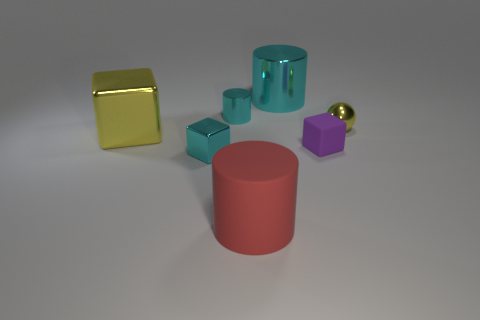Are there any large objects of the same color as the metallic sphere?
Ensure brevity in your answer.  Yes. Does the big cylinder behind the ball have the same color as the tiny shiny cylinder?
Provide a succinct answer. Yes. What number of objects are yellow things left of the rubber block or shiny things?
Give a very brief answer. 5. There is a tiny yellow shiny object; are there any big objects in front of it?
Give a very brief answer. Yes. There is a big block that is the same color as the shiny ball; what is it made of?
Provide a succinct answer. Metal. Are the tiny cylinder on the right side of the yellow metallic cube and the purple cube made of the same material?
Your answer should be very brief. No. Is there a yellow thing on the right side of the tiny cyan object in front of the metal cylinder that is in front of the large cyan metallic cylinder?
Your response must be concise. Yes. How many cubes are purple matte things or large green metallic things?
Your response must be concise. 1. What is the small thing behind the small ball made of?
Your answer should be compact. Metal. There is a cube that is the same color as the small cylinder; what size is it?
Your answer should be very brief. Small. 